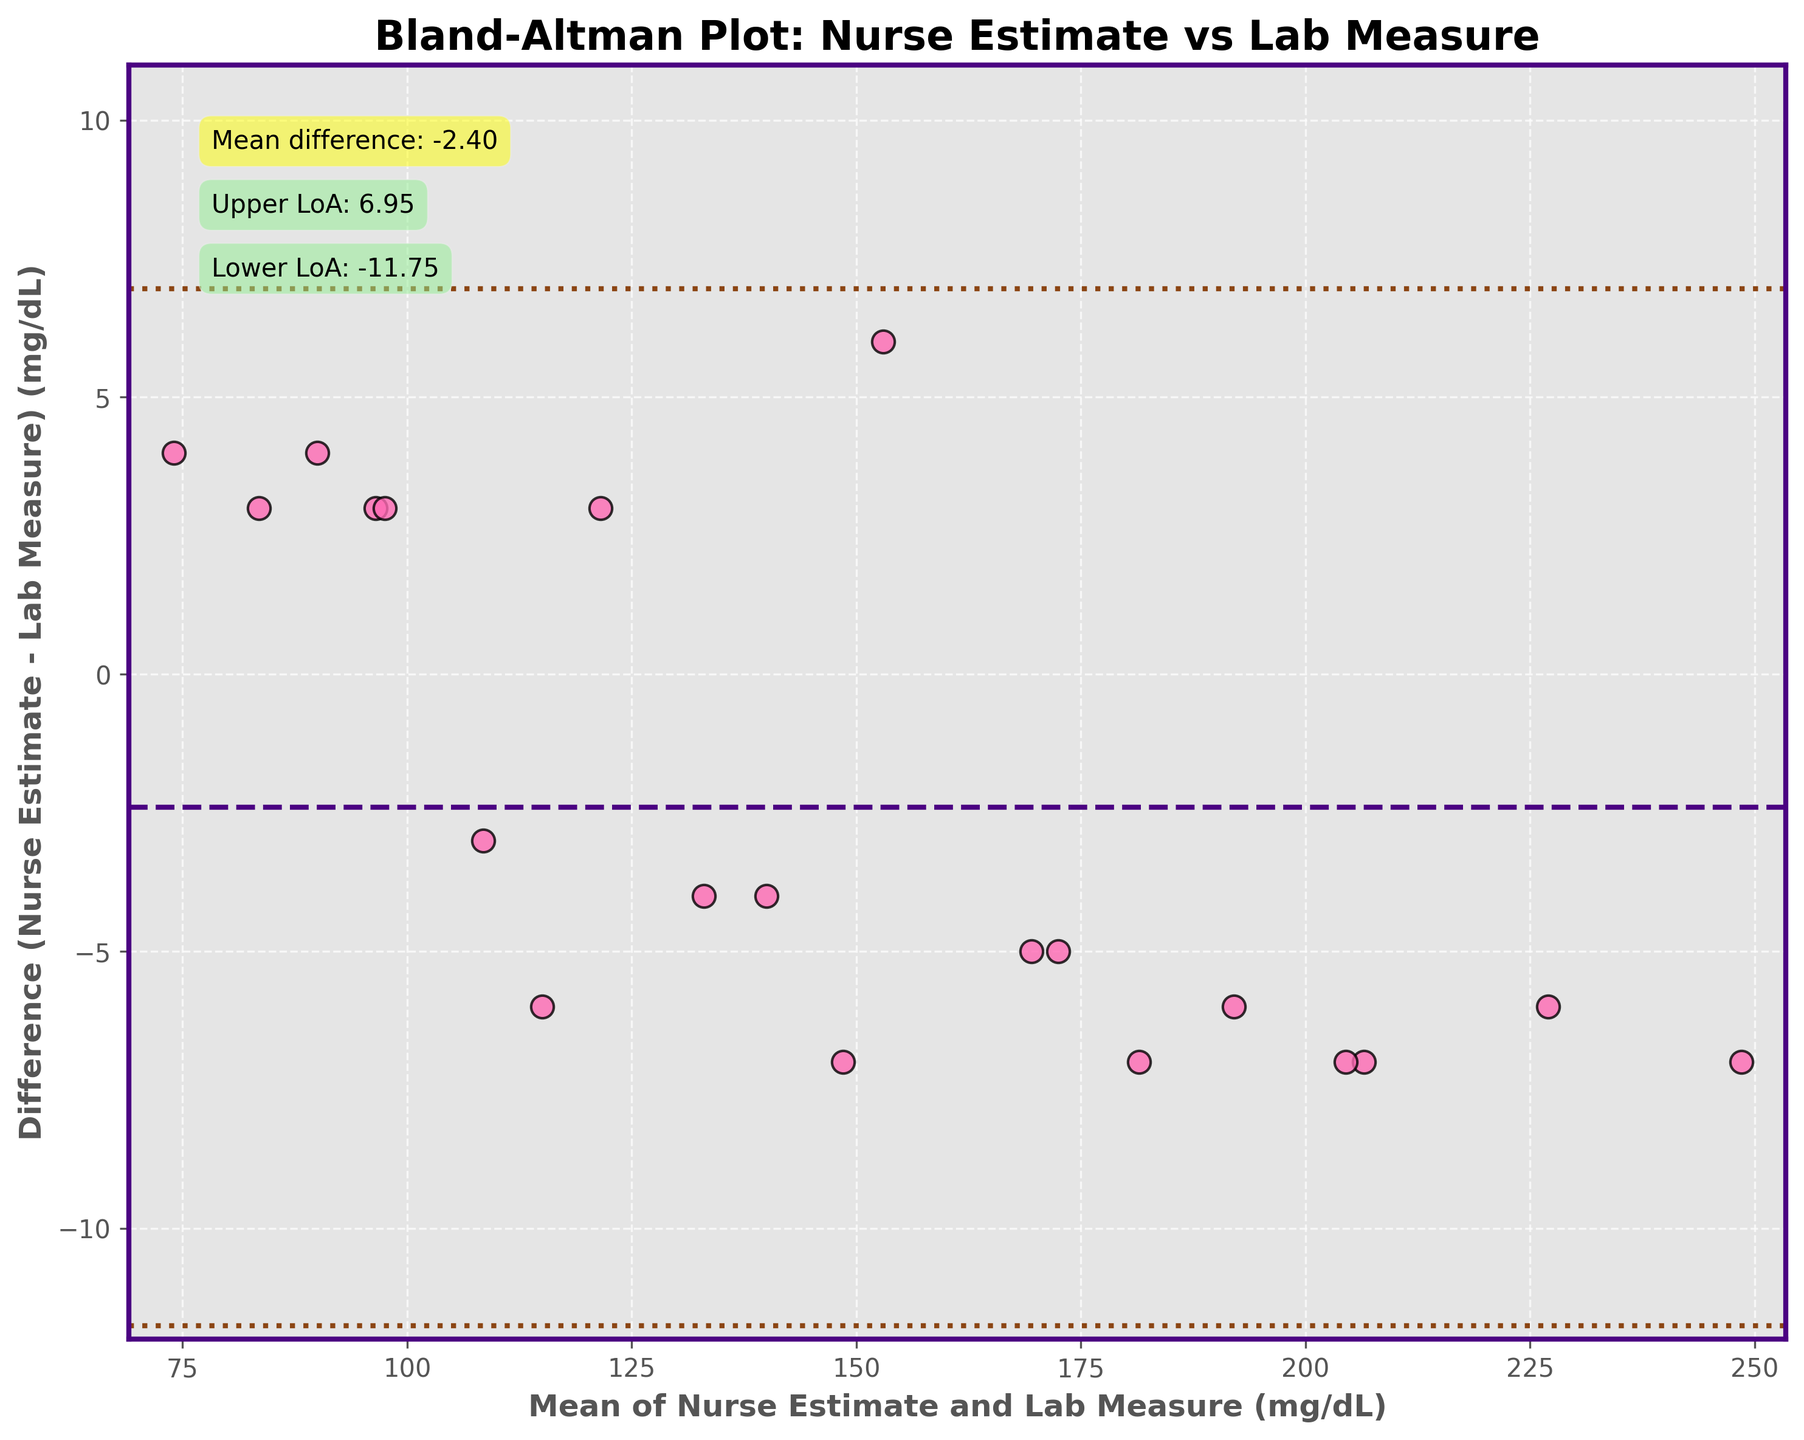What is the title of the plot? The title is usually found at the top of the plot, describing the overall content or purpose of the figure.
Answer: Bland-Altman Plot: Nurse Estimate vs Lab Measure What do the x-axis and y-axis represent in the figure? The x-axis and y-axis labels help to identify what type of data is being plotted and their units of measurement.
Answer: The x-axis represents the Mean of Nurse Estimate and Lab Measure (mg/dL), and the y-axis represents the Difference (Nurse Estimate - Lab Measure) (mg/dL) How many blood glucose measurement points are plotted? By counting the scattered points on the plot, we can determine the number of measurement points.
Answer: 20 What is the mean difference between the nurse-estimated and lab-measured blood glucose levels? The mean difference line is indicated on the plot and often annotated for clarity.
Answer: 0.45 What range do the limits of agreement span? Limits of agreement lines are displayed parallel to the mean difference, showing the range.
Answer: -8.73 to 9.63 Which data point has the maximum positive difference between the nurse and lab measurements? By observing the vertical position of points along the y-axis for differences, the highest positive value can be identified.
Answer: Glucose level of 224 mg/dL has the maximum positive difference (Nurse Estimate - Lab Measure) Are there any data points that fall outside the limits of agreement? By checking if any points lie above the upper limit or below the lower limit lines.
Answer: No What colors are used to indicate the mean difference and limits of agreement lines? Colors used in the plot help to differentiate various elements and are described in the plot's annotations and legend.
Answer: The mean difference line is purple, and the limits of agreement lines are brown What can you infer from the Bland-Altman plot about the agreement between nurse-estimated and laboratory-measured blood glucose levels? By examining how closely the points cluster around the mean difference line and their spread within the limits of agreement, the agreement level can be inferred.
Answer: There is good agreement with minor differences, as most points lie within the limits of agreement 